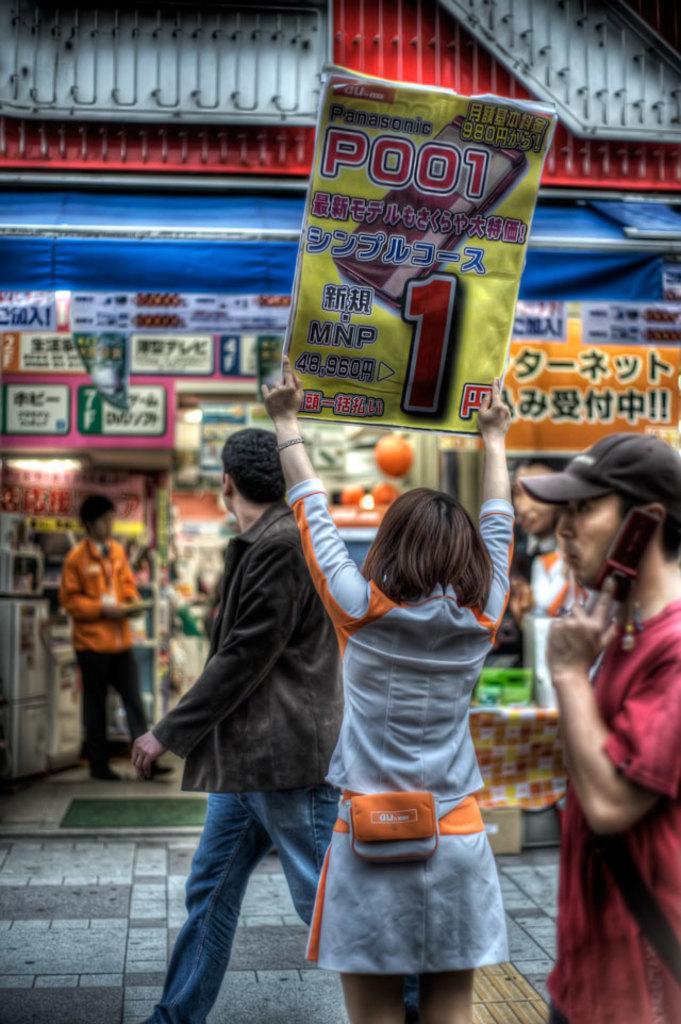In one or two sentences, can you explain what this image depicts? In this picture we can see four persons, a man on the right side is holding a mobile phone, he wore a cap, this girl is holding a paper, this man is walking, in the background there are some hoardings. 